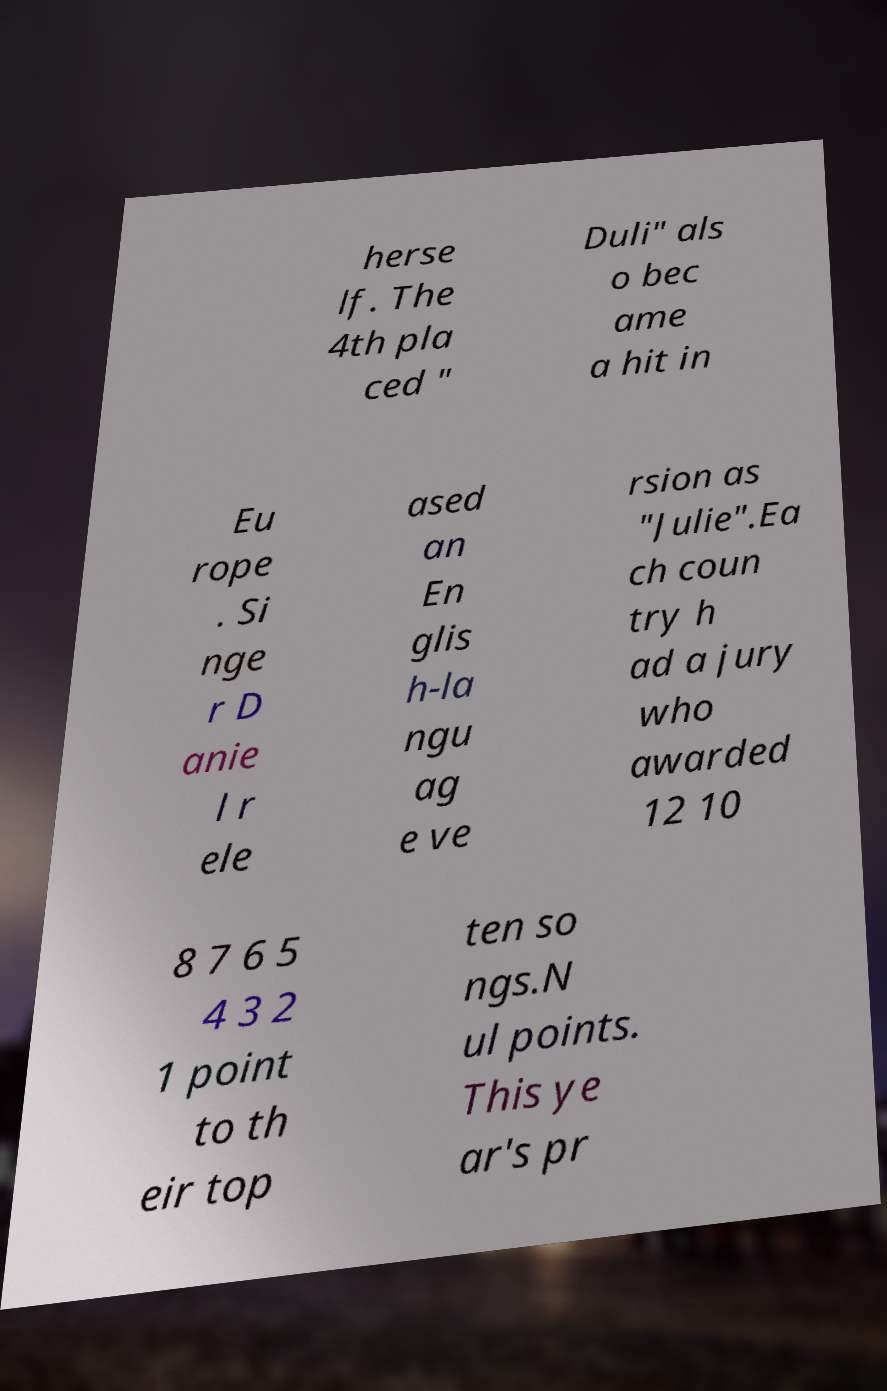I need the written content from this picture converted into text. Can you do that? herse lf. The 4th pla ced " Duli" als o bec ame a hit in Eu rope . Si nge r D anie l r ele ased an En glis h-la ngu ag e ve rsion as "Julie".Ea ch coun try h ad a jury who awarded 12 10 8 7 6 5 4 3 2 1 point to th eir top ten so ngs.N ul points. This ye ar's pr 